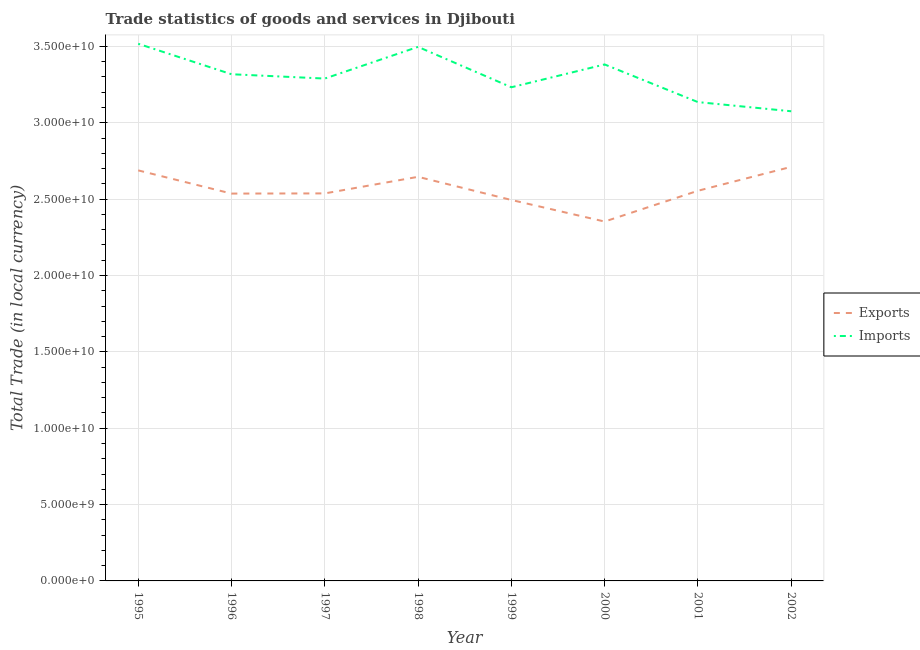How many different coloured lines are there?
Your answer should be compact. 2. What is the export of goods and services in 1995?
Provide a short and direct response. 2.69e+1. Across all years, what is the maximum export of goods and services?
Your response must be concise. 2.71e+1. Across all years, what is the minimum export of goods and services?
Keep it short and to the point. 2.35e+1. What is the total export of goods and services in the graph?
Provide a short and direct response. 2.05e+11. What is the difference between the export of goods and services in 1998 and that in 2002?
Offer a terse response. -6.53e+08. What is the difference between the export of goods and services in 1996 and the imports of goods and services in 1997?
Provide a short and direct response. -7.53e+09. What is the average export of goods and services per year?
Make the answer very short. 2.57e+1. In the year 1996, what is the difference between the imports of goods and services and export of goods and services?
Give a very brief answer. 7.81e+09. What is the ratio of the imports of goods and services in 1995 to that in 2002?
Offer a terse response. 1.14. Is the difference between the imports of goods and services in 2000 and 2001 greater than the difference between the export of goods and services in 2000 and 2001?
Give a very brief answer. Yes. What is the difference between the highest and the second highest export of goods and services?
Your response must be concise. 2.31e+08. What is the difference between the highest and the lowest imports of goods and services?
Make the answer very short. 4.42e+09. Does the imports of goods and services monotonically increase over the years?
Make the answer very short. No. What is the difference between two consecutive major ticks on the Y-axis?
Offer a terse response. 5.00e+09. Are the values on the major ticks of Y-axis written in scientific E-notation?
Keep it short and to the point. Yes. Does the graph contain any zero values?
Make the answer very short. No. Where does the legend appear in the graph?
Ensure brevity in your answer.  Center right. How many legend labels are there?
Keep it short and to the point. 2. How are the legend labels stacked?
Keep it short and to the point. Vertical. What is the title of the graph?
Offer a terse response. Trade statistics of goods and services in Djibouti. What is the label or title of the Y-axis?
Offer a terse response. Total Trade (in local currency). What is the Total Trade (in local currency) of Exports in 1995?
Your answer should be very brief. 2.69e+1. What is the Total Trade (in local currency) in Imports in 1995?
Keep it short and to the point. 3.52e+1. What is the Total Trade (in local currency) in Exports in 1996?
Offer a very short reply. 2.54e+1. What is the Total Trade (in local currency) in Imports in 1996?
Your answer should be very brief. 3.32e+1. What is the Total Trade (in local currency) of Exports in 1997?
Offer a very short reply. 2.54e+1. What is the Total Trade (in local currency) in Imports in 1997?
Give a very brief answer. 3.29e+1. What is the Total Trade (in local currency) in Exports in 1998?
Offer a very short reply. 2.65e+1. What is the Total Trade (in local currency) in Imports in 1998?
Your response must be concise. 3.50e+1. What is the Total Trade (in local currency) of Exports in 1999?
Provide a short and direct response. 2.49e+1. What is the Total Trade (in local currency) of Imports in 1999?
Provide a short and direct response. 3.23e+1. What is the Total Trade (in local currency) of Exports in 2000?
Provide a short and direct response. 2.35e+1. What is the Total Trade (in local currency) of Imports in 2000?
Your answer should be compact. 3.38e+1. What is the Total Trade (in local currency) in Exports in 2001?
Your response must be concise. 2.55e+1. What is the Total Trade (in local currency) of Imports in 2001?
Provide a short and direct response. 3.14e+1. What is the Total Trade (in local currency) of Exports in 2002?
Your response must be concise. 2.71e+1. What is the Total Trade (in local currency) in Imports in 2002?
Your answer should be compact. 3.08e+1. Across all years, what is the maximum Total Trade (in local currency) of Exports?
Give a very brief answer. 2.71e+1. Across all years, what is the maximum Total Trade (in local currency) in Imports?
Offer a terse response. 3.52e+1. Across all years, what is the minimum Total Trade (in local currency) of Exports?
Give a very brief answer. 2.35e+1. Across all years, what is the minimum Total Trade (in local currency) in Imports?
Give a very brief answer. 3.08e+1. What is the total Total Trade (in local currency) in Exports in the graph?
Your answer should be compact. 2.05e+11. What is the total Total Trade (in local currency) of Imports in the graph?
Your response must be concise. 2.64e+11. What is the difference between the Total Trade (in local currency) in Exports in 1995 and that in 1996?
Your answer should be very brief. 1.52e+09. What is the difference between the Total Trade (in local currency) of Imports in 1995 and that in 1996?
Make the answer very short. 2.00e+09. What is the difference between the Total Trade (in local currency) of Exports in 1995 and that in 1997?
Ensure brevity in your answer.  1.51e+09. What is the difference between the Total Trade (in local currency) in Imports in 1995 and that in 1997?
Give a very brief answer. 2.28e+09. What is the difference between the Total Trade (in local currency) in Exports in 1995 and that in 1998?
Your answer should be compact. 4.22e+08. What is the difference between the Total Trade (in local currency) in Imports in 1995 and that in 1998?
Provide a succinct answer. 2.03e+08. What is the difference between the Total Trade (in local currency) in Exports in 1995 and that in 1999?
Give a very brief answer. 1.94e+09. What is the difference between the Total Trade (in local currency) in Imports in 1995 and that in 1999?
Your answer should be compact. 2.85e+09. What is the difference between the Total Trade (in local currency) of Exports in 1995 and that in 2000?
Provide a succinct answer. 3.35e+09. What is the difference between the Total Trade (in local currency) in Imports in 1995 and that in 2000?
Your answer should be compact. 1.35e+09. What is the difference between the Total Trade (in local currency) in Exports in 1995 and that in 2001?
Provide a short and direct response. 1.34e+09. What is the difference between the Total Trade (in local currency) of Imports in 1995 and that in 2001?
Ensure brevity in your answer.  3.82e+09. What is the difference between the Total Trade (in local currency) in Exports in 1995 and that in 2002?
Provide a succinct answer. -2.31e+08. What is the difference between the Total Trade (in local currency) in Imports in 1995 and that in 2002?
Make the answer very short. 4.42e+09. What is the difference between the Total Trade (in local currency) in Exports in 1996 and that in 1997?
Offer a very short reply. -1.16e+07. What is the difference between the Total Trade (in local currency) in Imports in 1996 and that in 1997?
Provide a succinct answer. 2.83e+08. What is the difference between the Total Trade (in local currency) of Exports in 1996 and that in 1998?
Your answer should be compact. -1.10e+09. What is the difference between the Total Trade (in local currency) of Imports in 1996 and that in 1998?
Keep it short and to the point. -1.79e+09. What is the difference between the Total Trade (in local currency) of Exports in 1996 and that in 1999?
Ensure brevity in your answer.  4.19e+08. What is the difference between the Total Trade (in local currency) in Imports in 1996 and that in 1999?
Make the answer very short. 8.53e+08. What is the difference between the Total Trade (in local currency) in Exports in 1996 and that in 2000?
Give a very brief answer. 1.83e+09. What is the difference between the Total Trade (in local currency) in Imports in 1996 and that in 2000?
Keep it short and to the point. -6.41e+08. What is the difference between the Total Trade (in local currency) of Exports in 1996 and that in 2001?
Give a very brief answer. -1.84e+08. What is the difference between the Total Trade (in local currency) in Imports in 1996 and that in 2001?
Your answer should be compact. 1.82e+09. What is the difference between the Total Trade (in local currency) of Exports in 1996 and that in 2002?
Your answer should be very brief. -1.75e+09. What is the difference between the Total Trade (in local currency) of Imports in 1996 and that in 2002?
Make the answer very short. 2.42e+09. What is the difference between the Total Trade (in local currency) in Exports in 1997 and that in 1998?
Offer a very short reply. -1.09e+09. What is the difference between the Total Trade (in local currency) of Imports in 1997 and that in 1998?
Your answer should be compact. -2.08e+09. What is the difference between the Total Trade (in local currency) in Exports in 1997 and that in 1999?
Provide a short and direct response. 4.30e+08. What is the difference between the Total Trade (in local currency) in Imports in 1997 and that in 1999?
Your response must be concise. 5.70e+08. What is the difference between the Total Trade (in local currency) in Exports in 1997 and that in 2000?
Provide a succinct answer. 1.84e+09. What is the difference between the Total Trade (in local currency) in Imports in 1997 and that in 2000?
Give a very brief answer. -9.24e+08. What is the difference between the Total Trade (in local currency) in Exports in 1997 and that in 2001?
Your answer should be compact. -1.72e+08. What is the difference between the Total Trade (in local currency) of Imports in 1997 and that in 2001?
Your answer should be compact. 1.54e+09. What is the difference between the Total Trade (in local currency) in Exports in 1997 and that in 2002?
Provide a short and direct response. -1.74e+09. What is the difference between the Total Trade (in local currency) of Imports in 1997 and that in 2002?
Ensure brevity in your answer.  2.14e+09. What is the difference between the Total Trade (in local currency) in Exports in 1998 and that in 1999?
Your answer should be very brief. 1.52e+09. What is the difference between the Total Trade (in local currency) of Imports in 1998 and that in 1999?
Ensure brevity in your answer.  2.65e+09. What is the difference between the Total Trade (in local currency) of Exports in 1998 and that in 2000?
Offer a terse response. 2.93e+09. What is the difference between the Total Trade (in local currency) of Imports in 1998 and that in 2000?
Offer a terse response. 1.15e+09. What is the difference between the Total Trade (in local currency) in Exports in 1998 and that in 2001?
Your response must be concise. 9.13e+08. What is the difference between the Total Trade (in local currency) of Imports in 1998 and that in 2001?
Make the answer very short. 3.62e+09. What is the difference between the Total Trade (in local currency) of Exports in 1998 and that in 2002?
Provide a short and direct response. -6.53e+08. What is the difference between the Total Trade (in local currency) of Imports in 1998 and that in 2002?
Your response must be concise. 4.22e+09. What is the difference between the Total Trade (in local currency) of Exports in 1999 and that in 2000?
Offer a terse response. 1.41e+09. What is the difference between the Total Trade (in local currency) of Imports in 1999 and that in 2000?
Your answer should be very brief. -1.49e+09. What is the difference between the Total Trade (in local currency) in Exports in 1999 and that in 2001?
Your answer should be compact. -6.03e+08. What is the difference between the Total Trade (in local currency) of Imports in 1999 and that in 2001?
Make the answer very short. 9.71e+08. What is the difference between the Total Trade (in local currency) of Exports in 1999 and that in 2002?
Your answer should be very brief. -2.17e+09. What is the difference between the Total Trade (in local currency) in Imports in 1999 and that in 2002?
Provide a short and direct response. 1.57e+09. What is the difference between the Total Trade (in local currency) of Exports in 2000 and that in 2001?
Keep it short and to the point. -2.02e+09. What is the difference between the Total Trade (in local currency) in Imports in 2000 and that in 2001?
Provide a short and direct response. 2.47e+09. What is the difference between the Total Trade (in local currency) of Exports in 2000 and that in 2002?
Ensure brevity in your answer.  -3.58e+09. What is the difference between the Total Trade (in local currency) of Imports in 2000 and that in 2002?
Your response must be concise. 3.07e+09. What is the difference between the Total Trade (in local currency) of Exports in 2001 and that in 2002?
Provide a short and direct response. -1.57e+09. What is the difference between the Total Trade (in local currency) in Imports in 2001 and that in 2002?
Your answer should be very brief. 6.00e+08. What is the difference between the Total Trade (in local currency) in Exports in 1995 and the Total Trade (in local currency) in Imports in 1996?
Offer a very short reply. -6.30e+09. What is the difference between the Total Trade (in local currency) in Exports in 1995 and the Total Trade (in local currency) in Imports in 1997?
Your response must be concise. -6.01e+09. What is the difference between the Total Trade (in local currency) of Exports in 1995 and the Total Trade (in local currency) of Imports in 1998?
Your response must be concise. -8.09e+09. What is the difference between the Total Trade (in local currency) in Exports in 1995 and the Total Trade (in local currency) in Imports in 1999?
Your response must be concise. -5.44e+09. What is the difference between the Total Trade (in local currency) of Exports in 1995 and the Total Trade (in local currency) of Imports in 2000?
Give a very brief answer. -6.94e+09. What is the difference between the Total Trade (in local currency) in Exports in 1995 and the Total Trade (in local currency) in Imports in 2001?
Your answer should be very brief. -4.47e+09. What is the difference between the Total Trade (in local currency) of Exports in 1995 and the Total Trade (in local currency) of Imports in 2002?
Keep it short and to the point. -3.87e+09. What is the difference between the Total Trade (in local currency) of Exports in 1996 and the Total Trade (in local currency) of Imports in 1997?
Keep it short and to the point. -7.53e+09. What is the difference between the Total Trade (in local currency) in Exports in 1996 and the Total Trade (in local currency) in Imports in 1998?
Ensure brevity in your answer.  -9.61e+09. What is the difference between the Total Trade (in local currency) in Exports in 1996 and the Total Trade (in local currency) in Imports in 1999?
Give a very brief answer. -6.96e+09. What is the difference between the Total Trade (in local currency) in Exports in 1996 and the Total Trade (in local currency) in Imports in 2000?
Offer a very short reply. -8.46e+09. What is the difference between the Total Trade (in local currency) in Exports in 1996 and the Total Trade (in local currency) in Imports in 2001?
Your answer should be compact. -5.99e+09. What is the difference between the Total Trade (in local currency) in Exports in 1996 and the Total Trade (in local currency) in Imports in 2002?
Your answer should be compact. -5.39e+09. What is the difference between the Total Trade (in local currency) in Exports in 1997 and the Total Trade (in local currency) in Imports in 1998?
Keep it short and to the point. -9.60e+09. What is the difference between the Total Trade (in local currency) of Exports in 1997 and the Total Trade (in local currency) of Imports in 1999?
Your answer should be compact. -6.95e+09. What is the difference between the Total Trade (in local currency) of Exports in 1997 and the Total Trade (in local currency) of Imports in 2000?
Your response must be concise. -8.44e+09. What is the difference between the Total Trade (in local currency) of Exports in 1997 and the Total Trade (in local currency) of Imports in 2001?
Give a very brief answer. -5.98e+09. What is the difference between the Total Trade (in local currency) in Exports in 1997 and the Total Trade (in local currency) in Imports in 2002?
Provide a short and direct response. -5.38e+09. What is the difference between the Total Trade (in local currency) of Exports in 1998 and the Total Trade (in local currency) of Imports in 1999?
Your response must be concise. -5.86e+09. What is the difference between the Total Trade (in local currency) of Exports in 1998 and the Total Trade (in local currency) of Imports in 2000?
Make the answer very short. -7.36e+09. What is the difference between the Total Trade (in local currency) of Exports in 1998 and the Total Trade (in local currency) of Imports in 2001?
Make the answer very short. -4.89e+09. What is the difference between the Total Trade (in local currency) of Exports in 1998 and the Total Trade (in local currency) of Imports in 2002?
Provide a short and direct response. -4.29e+09. What is the difference between the Total Trade (in local currency) in Exports in 1999 and the Total Trade (in local currency) in Imports in 2000?
Provide a succinct answer. -8.87e+09. What is the difference between the Total Trade (in local currency) of Exports in 1999 and the Total Trade (in local currency) of Imports in 2001?
Give a very brief answer. -6.41e+09. What is the difference between the Total Trade (in local currency) of Exports in 1999 and the Total Trade (in local currency) of Imports in 2002?
Keep it short and to the point. -5.81e+09. What is the difference between the Total Trade (in local currency) in Exports in 2000 and the Total Trade (in local currency) in Imports in 2001?
Offer a terse response. -7.82e+09. What is the difference between the Total Trade (in local currency) of Exports in 2000 and the Total Trade (in local currency) of Imports in 2002?
Provide a short and direct response. -7.22e+09. What is the difference between the Total Trade (in local currency) of Exports in 2001 and the Total Trade (in local currency) of Imports in 2002?
Make the answer very short. -5.21e+09. What is the average Total Trade (in local currency) of Exports per year?
Make the answer very short. 2.57e+1. What is the average Total Trade (in local currency) in Imports per year?
Provide a short and direct response. 3.31e+1. In the year 1995, what is the difference between the Total Trade (in local currency) in Exports and Total Trade (in local currency) in Imports?
Ensure brevity in your answer.  -8.29e+09. In the year 1996, what is the difference between the Total Trade (in local currency) in Exports and Total Trade (in local currency) in Imports?
Provide a short and direct response. -7.81e+09. In the year 1997, what is the difference between the Total Trade (in local currency) in Exports and Total Trade (in local currency) in Imports?
Give a very brief answer. -7.52e+09. In the year 1998, what is the difference between the Total Trade (in local currency) of Exports and Total Trade (in local currency) of Imports?
Offer a very short reply. -8.51e+09. In the year 1999, what is the difference between the Total Trade (in local currency) in Exports and Total Trade (in local currency) in Imports?
Keep it short and to the point. -7.38e+09. In the year 2000, what is the difference between the Total Trade (in local currency) of Exports and Total Trade (in local currency) of Imports?
Give a very brief answer. -1.03e+1. In the year 2001, what is the difference between the Total Trade (in local currency) of Exports and Total Trade (in local currency) of Imports?
Your response must be concise. -5.81e+09. In the year 2002, what is the difference between the Total Trade (in local currency) in Exports and Total Trade (in local currency) in Imports?
Provide a succinct answer. -3.64e+09. What is the ratio of the Total Trade (in local currency) of Exports in 1995 to that in 1996?
Your answer should be very brief. 1.06. What is the ratio of the Total Trade (in local currency) in Imports in 1995 to that in 1996?
Offer a terse response. 1.06. What is the ratio of the Total Trade (in local currency) of Exports in 1995 to that in 1997?
Your answer should be compact. 1.06. What is the ratio of the Total Trade (in local currency) in Imports in 1995 to that in 1997?
Ensure brevity in your answer.  1.07. What is the ratio of the Total Trade (in local currency) in Exports in 1995 to that in 1998?
Offer a very short reply. 1.02. What is the ratio of the Total Trade (in local currency) in Exports in 1995 to that in 1999?
Make the answer very short. 1.08. What is the ratio of the Total Trade (in local currency) in Imports in 1995 to that in 1999?
Give a very brief answer. 1.09. What is the ratio of the Total Trade (in local currency) of Exports in 1995 to that in 2000?
Your answer should be compact. 1.14. What is the ratio of the Total Trade (in local currency) in Exports in 1995 to that in 2001?
Make the answer very short. 1.05. What is the ratio of the Total Trade (in local currency) of Imports in 1995 to that in 2001?
Your response must be concise. 1.12. What is the ratio of the Total Trade (in local currency) of Imports in 1995 to that in 2002?
Your answer should be very brief. 1.14. What is the ratio of the Total Trade (in local currency) in Exports in 1996 to that in 1997?
Your response must be concise. 1. What is the ratio of the Total Trade (in local currency) in Imports in 1996 to that in 1997?
Keep it short and to the point. 1.01. What is the ratio of the Total Trade (in local currency) in Exports in 1996 to that in 1998?
Offer a terse response. 0.96. What is the ratio of the Total Trade (in local currency) in Imports in 1996 to that in 1998?
Your answer should be compact. 0.95. What is the ratio of the Total Trade (in local currency) of Exports in 1996 to that in 1999?
Give a very brief answer. 1.02. What is the ratio of the Total Trade (in local currency) of Imports in 1996 to that in 1999?
Give a very brief answer. 1.03. What is the ratio of the Total Trade (in local currency) of Exports in 1996 to that in 2000?
Provide a succinct answer. 1.08. What is the ratio of the Total Trade (in local currency) in Imports in 1996 to that in 2001?
Give a very brief answer. 1.06. What is the ratio of the Total Trade (in local currency) of Exports in 1996 to that in 2002?
Your answer should be compact. 0.94. What is the ratio of the Total Trade (in local currency) of Imports in 1996 to that in 2002?
Offer a terse response. 1.08. What is the ratio of the Total Trade (in local currency) of Imports in 1997 to that in 1998?
Give a very brief answer. 0.94. What is the ratio of the Total Trade (in local currency) of Exports in 1997 to that in 1999?
Your answer should be very brief. 1.02. What is the ratio of the Total Trade (in local currency) of Imports in 1997 to that in 1999?
Your response must be concise. 1.02. What is the ratio of the Total Trade (in local currency) of Exports in 1997 to that in 2000?
Ensure brevity in your answer.  1.08. What is the ratio of the Total Trade (in local currency) of Imports in 1997 to that in 2000?
Offer a very short reply. 0.97. What is the ratio of the Total Trade (in local currency) of Imports in 1997 to that in 2001?
Ensure brevity in your answer.  1.05. What is the ratio of the Total Trade (in local currency) of Exports in 1997 to that in 2002?
Provide a succinct answer. 0.94. What is the ratio of the Total Trade (in local currency) of Imports in 1997 to that in 2002?
Offer a very short reply. 1.07. What is the ratio of the Total Trade (in local currency) in Exports in 1998 to that in 1999?
Offer a terse response. 1.06. What is the ratio of the Total Trade (in local currency) of Imports in 1998 to that in 1999?
Your answer should be very brief. 1.08. What is the ratio of the Total Trade (in local currency) in Exports in 1998 to that in 2000?
Give a very brief answer. 1.12. What is the ratio of the Total Trade (in local currency) of Imports in 1998 to that in 2000?
Keep it short and to the point. 1.03. What is the ratio of the Total Trade (in local currency) in Exports in 1998 to that in 2001?
Make the answer very short. 1.04. What is the ratio of the Total Trade (in local currency) of Imports in 1998 to that in 2001?
Provide a short and direct response. 1.12. What is the ratio of the Total Trade (in local currency) of Exports in 1998 to that in 2002?
Ensure brevity in your answer.  0.98. What is the ratio of the Total Trade (in local currency) in Imports in 1998 to that in 2002?
Offer a very short reply. 1.14. What is the ratio of the Total Trade (in local currency) of Exports in 1999 to that in 2000?
Offer a very short reply. 1.06. What is the ratio of the Total Trade (in local currency) in Imports in 1999 to that in 2000?
Provide a short and direct response. 0.96. What is the ratio of the Total Trade (in local currency) of Exports in 1999 to that in 2001?
Ensure brevity in your answer.  0.98. What is the ratio of the Total Trade (in local currency) of Imports in 1999 to that in 2001?
Offer a very short reply. 1.03. What is the ratio of the Total Trade (in local currency) in Exports in 1999 to that in 2002?
Ensure brevity in your answer.  0.92. What is the ratio of the Total Trade (in local currency) in Imports in 1999 to that in 2002?
Offer a terse response. 1.05. What is the ratio of the Total Trade (in local currency) of Exports in 2000 to that in 2001?
Provide a succinct answer. 0.92. What is the ratio of the Total Trade (in local currency) of Imports in 2000 to that in 2001?
Your answer should be very brief. 1.08. What is the ratio of the Total Trade (in local currency) of Exports in 2000 to that in 2002?
Make the answer very short. 0.87. What is the ratio of the Total Trade (in local currency) of Imports in 2000 to that in 2002?
Your response must be concise. 1.1. What is the ratio of the Total Trade (in local currency) of Exports in 2001 to that in 2002?
Keep it short and to the point. 0.94. What is the ratio of the Total Trade (in local currency) of Imports in 2001 to that in 2002?
Provide a short and direct response. 1.02. What is the difference between the highest and the second highest Total Trade (in local currency) in Exports?
Give a very brief answer. 2.31e+08. What is the difference between the highest and the second highest Total Trade (in local currency) of Imports?
Offer a terse response. 2.03e+08. What is the difference between the highest and the lowest Total Trade (in local currency) of Exports?
Your answer should be very brief. 3.58e+09. What is the difference between the highest and the lowest Total Trade (in local currency) in Imports?
Your answer should be compact. 4.42e+09. 